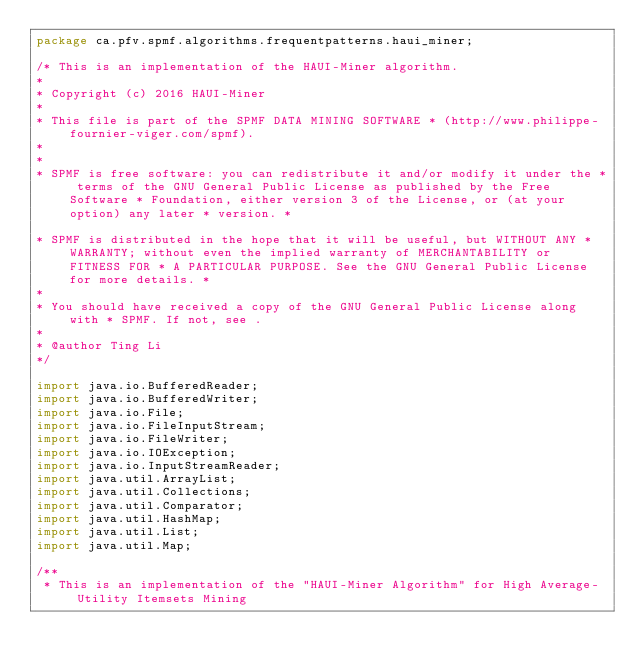<code> <loc_0><loc_0><loc_500><loc_500><_Java_>package ca.pfv.spmf.algorithms.frequentpatterns.haui_miner;

/* This is an implementation of the HAUI-Miner algorithm. 
* 
* Copyright (c) 2016 HAUI-Miner
* 
* This file is part of the SPMF DATA MINING SOFTWARE * (http://www.philippe-fournier-viger.com/spmf). 
* 
* 
* SPMF is free software: you can redistribute it and/or modify it under the * terms of the GNU General Public License as published by the Free Software * Foundation, either version 3 of the License, or (at your option) any later * version. * 

* SPMF is distributed in the hope that it will be useful, but WITHOUT ANY * WARRANTY; without even the implied warranty of MERCHANTABILITY or FITNESS FOR * A PARTICULAR PURPOSE. See the GNU General Public License for more details. * 
* 
* You should have received a copy of the GNU General Public License along with * SPMF. If not, see . 
* 
* @author Ting Li
*/

import java.io.BufferedReader;
import java.io.BufferedWriter;
import java.io.File;
import java.io.FileInputStream;
import java.io.FileWriter;
import java.io.IOException;
import java.io.InputStreamReader;
import java.util.ArrayList;
import java.util.Collections;
import java.util.Comparator;
import java.util.HashMap;
import java.util.List;
import java.util.Map;

/**
 * This is an implementation of the "HAUI-Miner Algorithm" for High Average-Utility Itemsets Mining</code> 